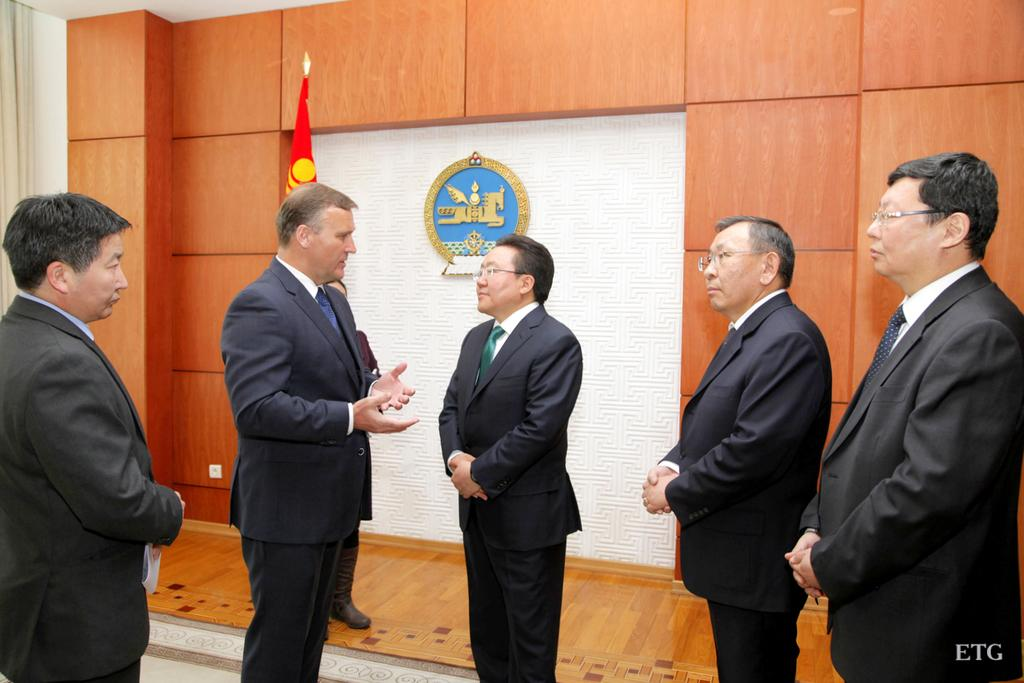What can be seen in the image? There are people standing in the image. What is visible in the background of the image? There is a wall, a curtain, a flag, and a logo on a white surface in the background of the image. What type of dress is the daughter wearing in the image? There is no daughter present in the image, and therefore no dress can be observed. Is there a bomb visible in the image? There is no bomb present in the image. 